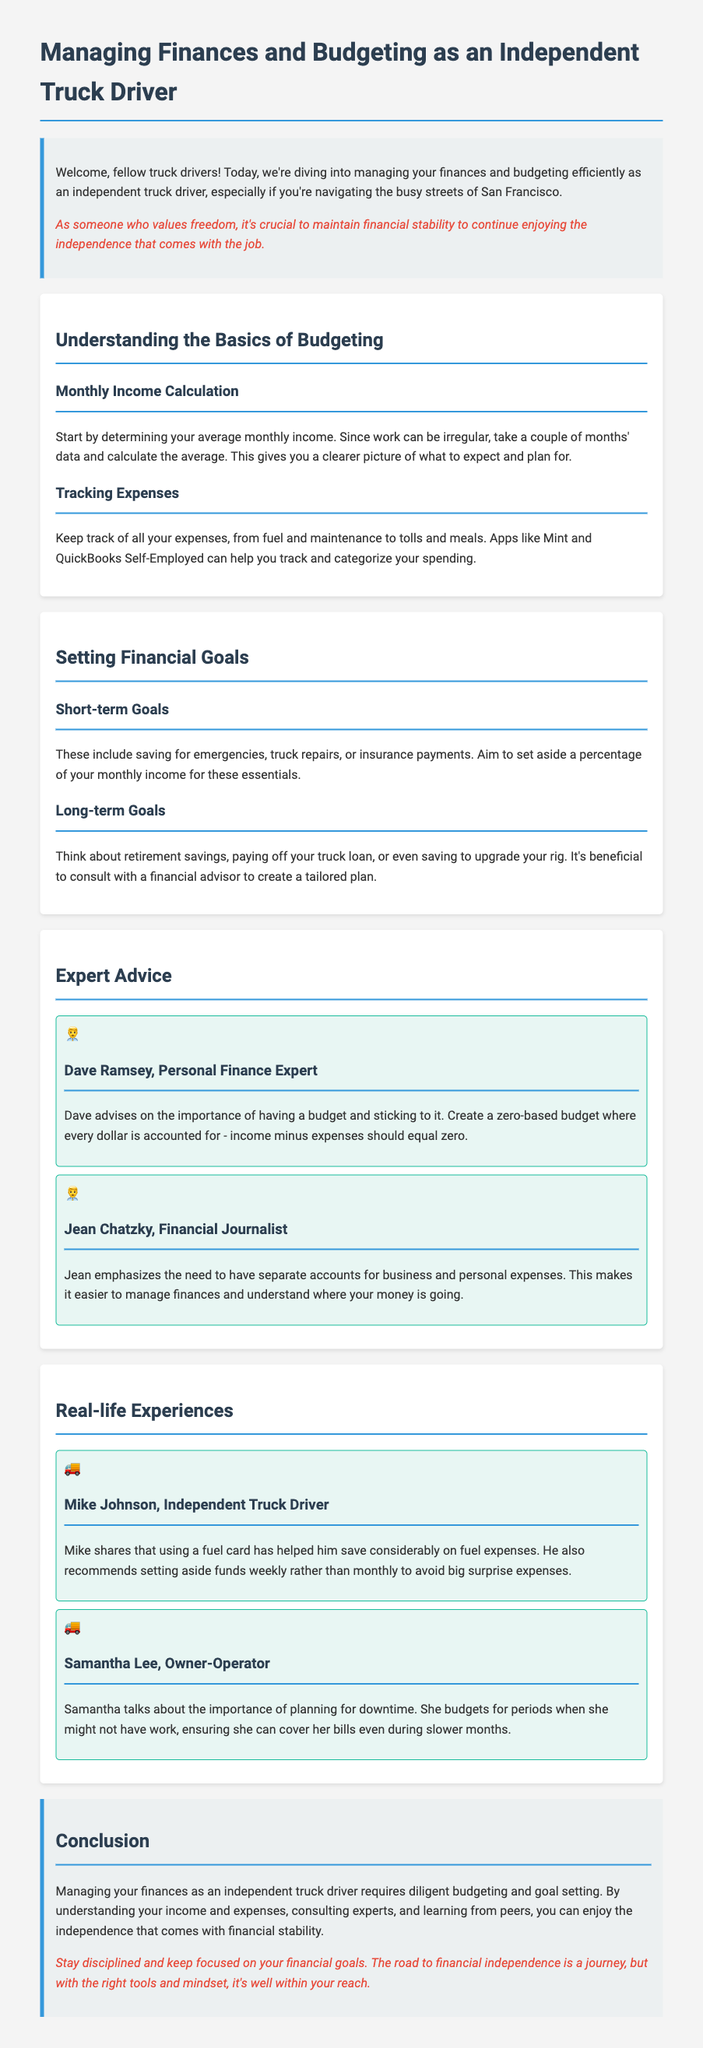What is the main topic of the document? The main topic is about managing finances and budgeting specifically for independent truck drivers.
Answer: Managing finances and budgeting Who provides advice on budgeting in the document? Dave Ramsey is named as a personal finance expert who gives budgeting advice.
Answer: Dave Ramsey What percentage should you aim to save for short-term goals? The document suggests setting aside a percentage of your monthly income for short-term financial goals.
Answer: Percentage of monthly income What tool is recommended for tracking expenses? The document mentions applications like Mint and QuickBooks Self-Employed for tracking expenses.
Answer: Mint and QuickBooks Self-Employed What did Mike Johnson recommend for fuel expenses? Mike Johnson recommends using a fuel card to help save on fuel expenses.
Answer: Fuel card What is a key strategy mentioned by Samantha Lee for downtime? Samantha Lee emphasizes budgeting for periods without work to cover bills during slower months.
Answer: Budgeting for downtime What should every dollar account for according to the expert advice? Every dollar should be accounted for in a zero-based budget, as mentioned by Dave Ramsey.
Answer: Zero-based budget What does the introduction emphasize about financial stability? The introduction emphasizes the importance of financial stability to maintain the freedom that comes with being an independent truck driver.
Answer: Financial stability What kind of goals should an independent truck driver set according to the document? Independent truck drivers should set both short-term and long-term financial goals.
Answer: Short-term and long-term goals 